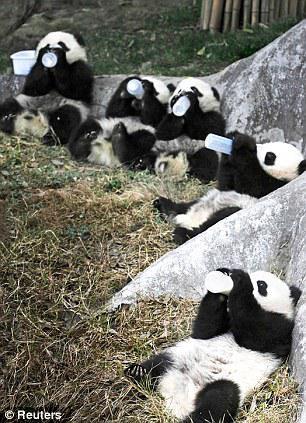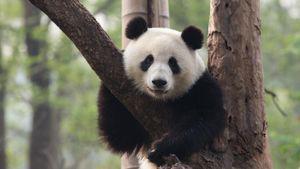The first image is the image on the left, the second image is the image on the right. Analyze the images presented: Is the assertion "Two pandas are on top of each other in one of the images." valid? Answer yes or no. No. The first image is the image on the left, the second image is the image on the right. Evaluate the accuracy of this statement regarding the images: "In one of the images there are exactly two pandas cuddled together.". Is it true? Answer yes or no. No. 